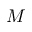Convert formula to latex. <formula><loc_0><loc_0><loc_500><loc_500>M</formula> 